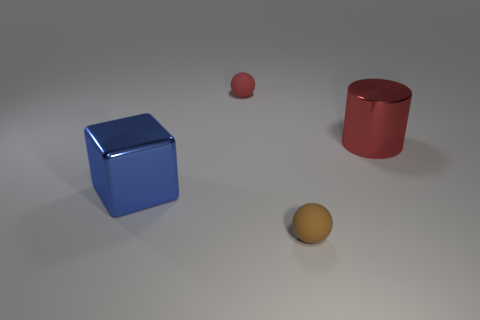Do the red sphere and the big thing that is to the left of the brown ball have the same material?
Offer a terse response. No. What material is the tiny ball right of the tiny rubber thing that is behind the cylinder?
Offer a terse response. Rubber. Are there more rubber spheres behind the red cylinder than tiny brown metal balls?
Keep it short and to the point. Yes. Are any big green objects visible?
Your answer should be compact. No. There is a rubber thing that is in front of the red ball; what is its color?
Offer a terse response. Brown. There is a cube that is the same size as the red shiny cylinder; what is its material?
Make the answer very short. Metal. How many other objects are the same material as the brown ball?
Keep it short and to the point. 1. What is the color of the object that is both behind the tiny brown sphere and to the right of the red matte sphere?
Give a very brief answer. Red. What number of objects are either rubber things in front of the big blue object or yellow metal cylinders?
Offer a very short reply. 1. How many other things are the same color as the large metallic cylinder?
Give a very brief answer. 1. 